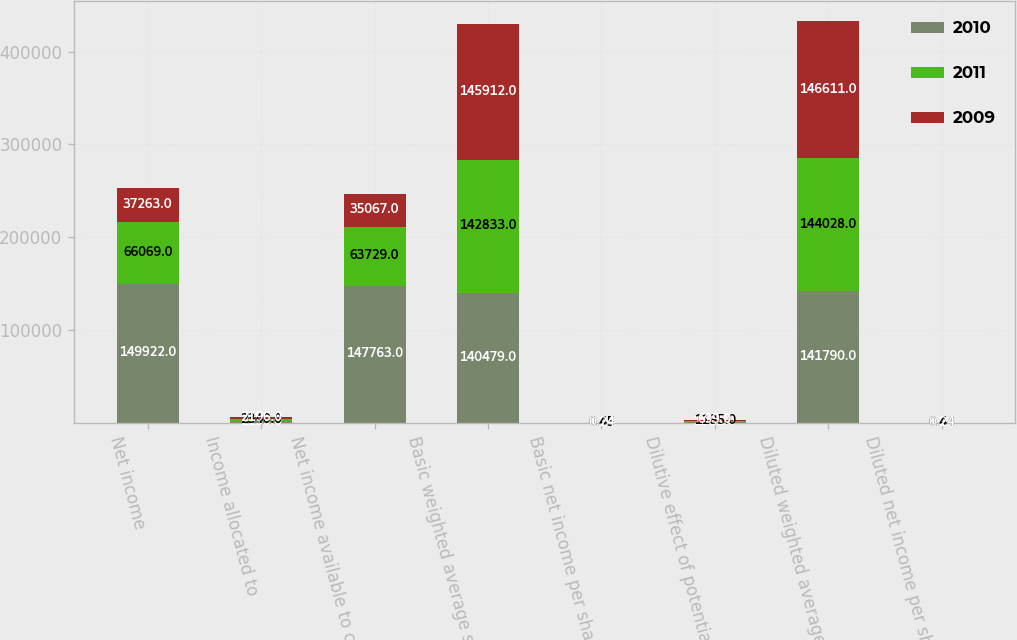<chart> <loc_0><loc_0><loc_500><loc_500><stacked_bar_chart><ecel><fcel>Net income<fcel>Income allocated to<fcel>Net income available to common<fcel>Basic weighted average shares<fcel>Basic net income per share<fcel>Dilutive effect of potential<fcel>Diluted weighted average<fcel>Diluted net income per share<nl><fcel>2010<fcel>149922<fcel>2159<fcel>147763<fcel>140479<fcel>1.05<fcel>1311<fcel>141790<fcel>1.04<nl><fcel>2011<fcel>66069<fcel>2340<fcel>63729<fcel>142833<fcel>0.45<fcel>1195<fcel>144028<fcel>0.44<nl><fcel>2009<fcel>37263<fcel>2196<fcel>35067<fcel>145912<fcel>0.24<fcel>699<fcel>146611<fcel>0.24<nl></chart> 